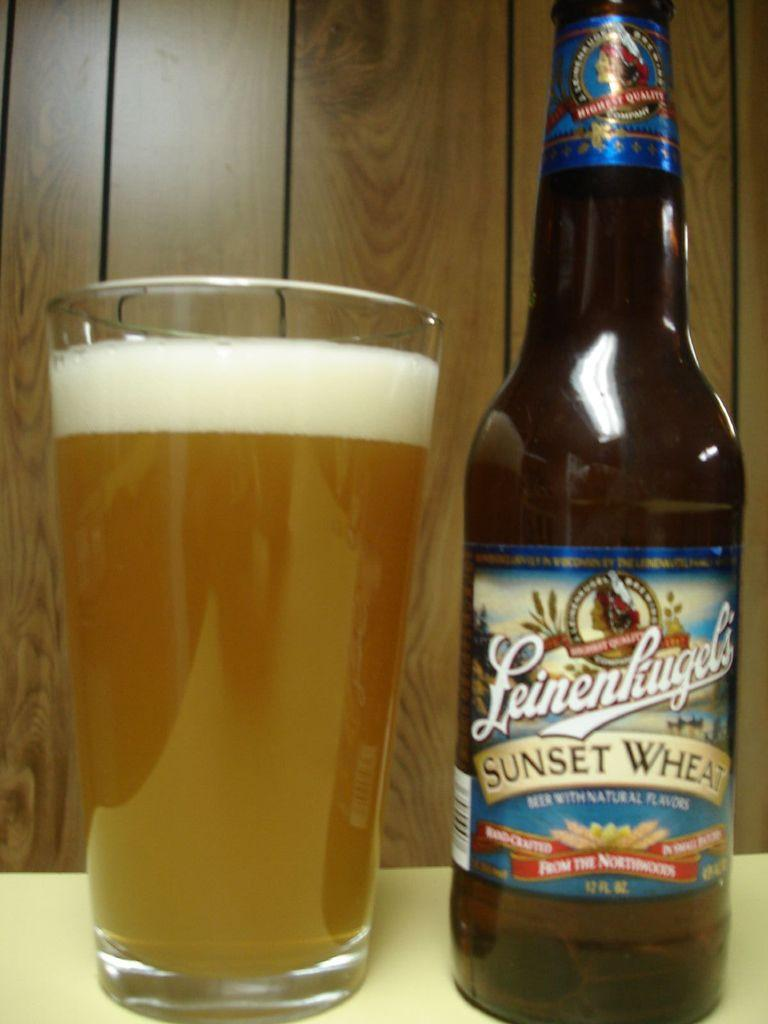What type of beverage is featured in the image? There is a beer bottle and a glass of beer in the image. Where are the beer bottle and glass of beer located? They are placed on a surface in the image. What else can be seen in the background of the image? There is a wall visible in the image. Can you see a monkey climbing the wall in the image? No, there is no monkey present in the image. What type of wave is visible in the image? There is no wave visible in the image; it features a beer bottle and glass of beer on a surface with a wall in the background. 